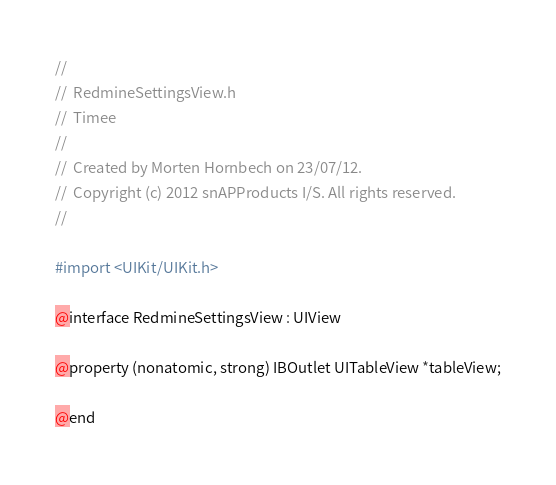<code> <loc_0><loc_0><loc_500><loc_500><_C_>//
//  RedmineSettingsView.h
//  Timee
//
//  Created by Morten Hornbech on 23/07/12.
//  Copyright (c) 2012 snAPProducts I/S. All rights reserved.
//

#import <UIKit/UIKit.h>

@interface RedmineSettingsView : UIView

@property (nonatomic, strong) IBOutlet UITableView *tableView;

@end
</code> 